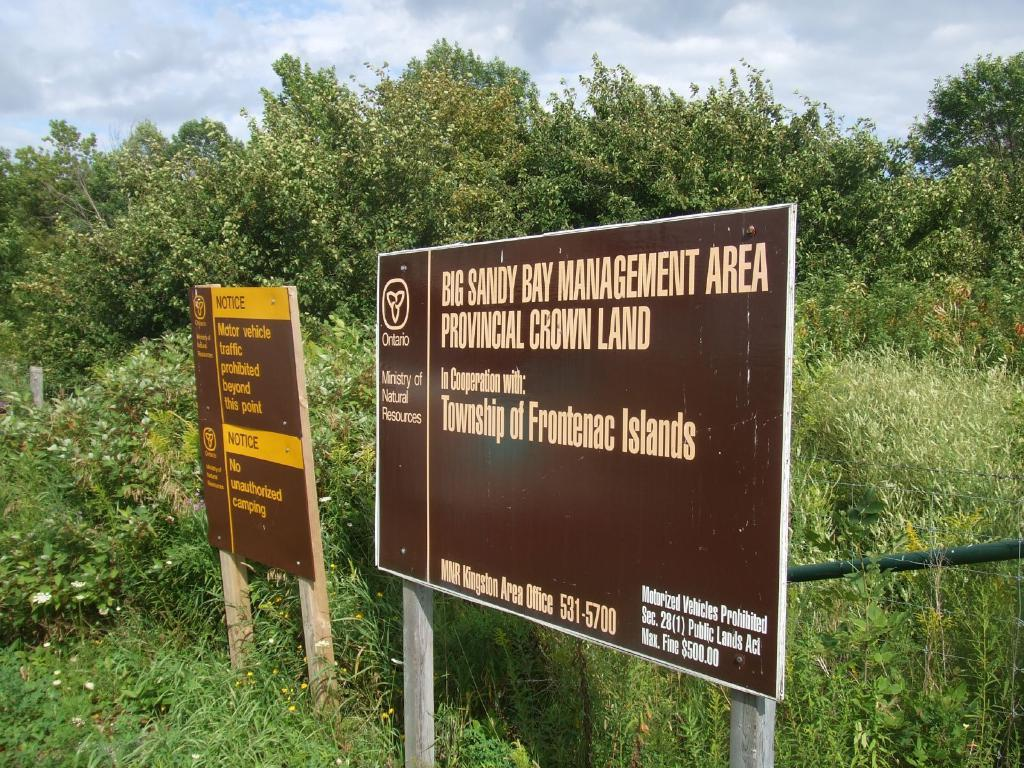What can be seen on the advertising boards in the image? There are two advertising boards with text in the image. What type of natural elements are visible in the background of the image? There are trees in the background of the image. What is visible at the top of the image? The sky is visible at the top of the image. How many boots are hanging from the trees in the image? There are no boots visible in the image; only trees are present in the background. 